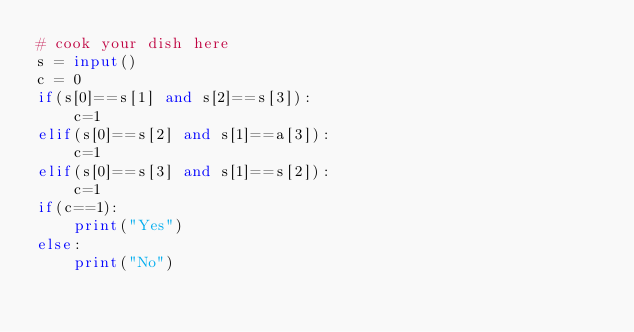<code> <loc_0><loc_0><loc_500><loc_500><_Python_># cook your dish here
s = input()
c = 0 
if(s[0]==s[1] and s[2]==s[3]):
    c=1 
elif(s[0]==s[2] and s[1]==a[3]):
    c=1 
elif(s[0]==s[3] and s[1]==s[2]):
    c=1 
if(c==1):
    print("Yes")
else:
    print("No")</code> 